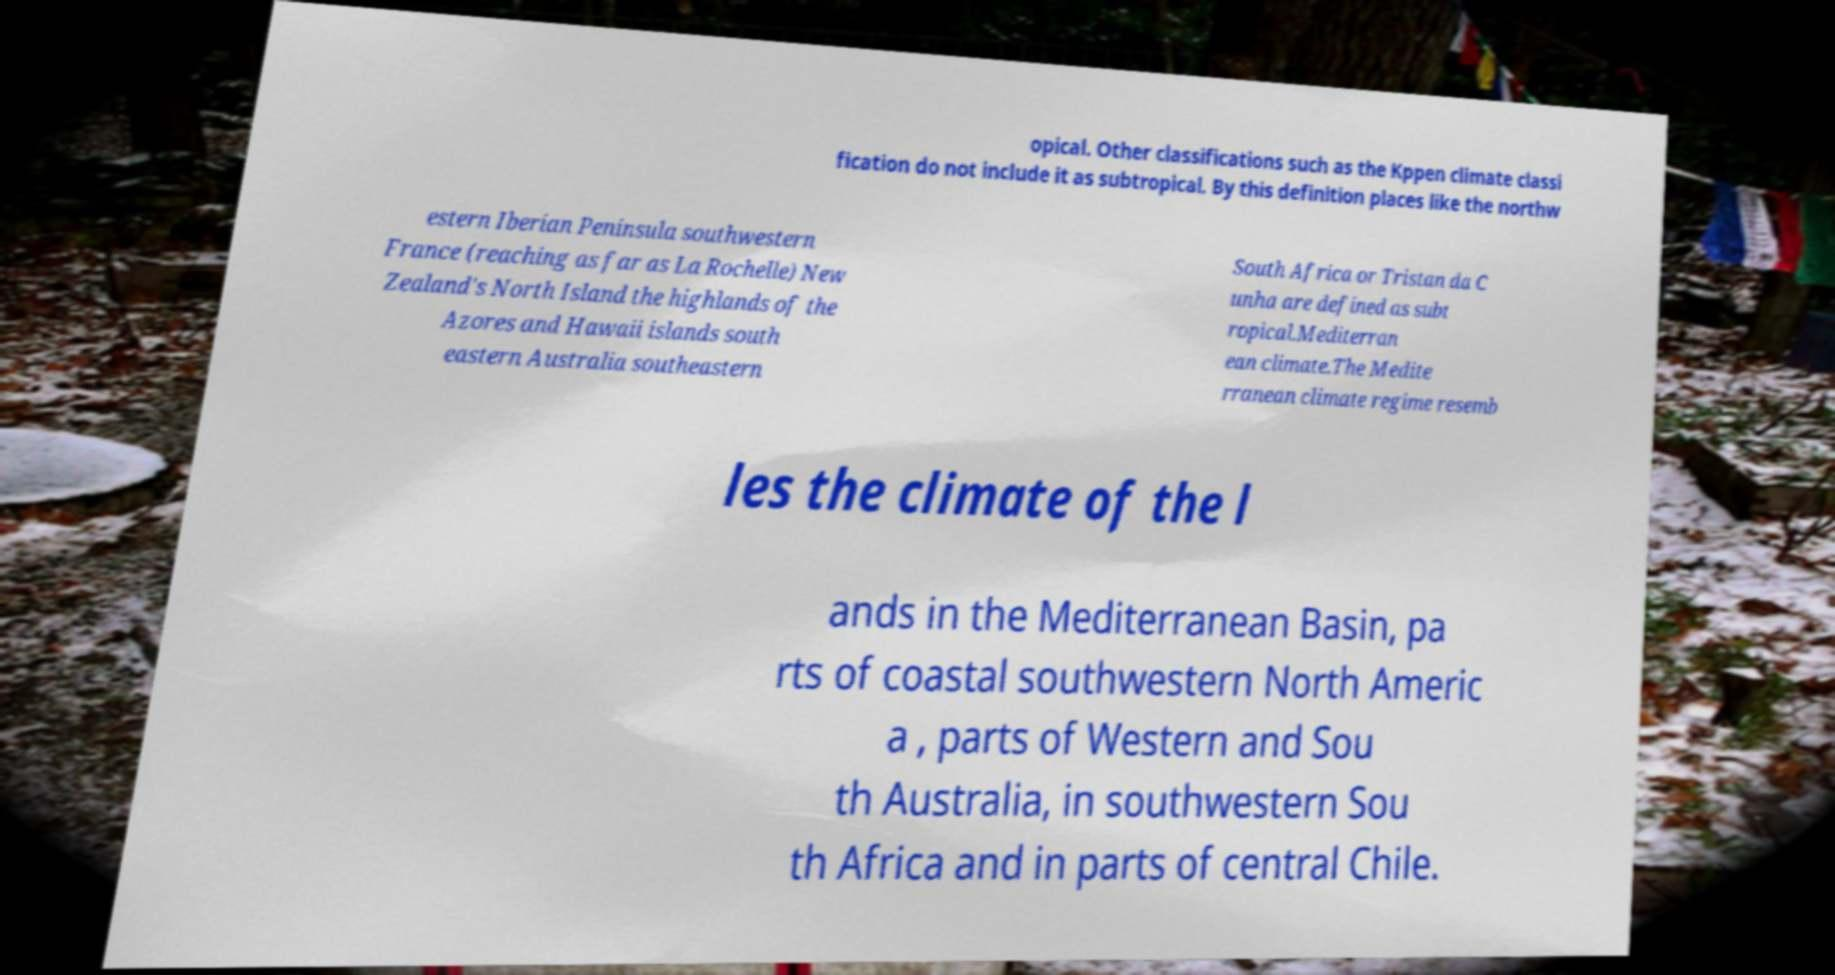Can you read and provide the text displayed in the image?This photo seems to have some interesting text. Can you extract and type it out for me? opical. Other classifications such as the Kppen climate classi fication do not include it as subtropical. By this definition places like the northw estern Iberian Peninsula southwestern France (reaching as far as La Rochelle) New Zealand's North Island the highlands of the Azores and Hawaii islands south eastern Australia southeastern South Africa or Tristan da C unha are defined as subt ropical.Mediterran ean climate.The Medite rranean climate regime resemb les the climate of the l ands in the Mediterranean Basin, pa rts of coastal southwestern North Americ a , parts of Western and Sou th Australia, in southwestern Sou th Africa and in parts of central Chile. 